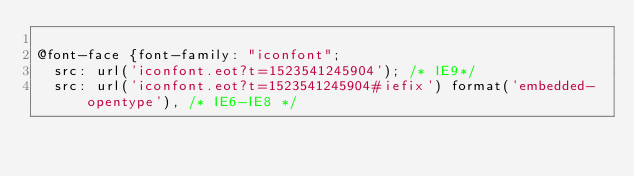Convert code to text. <code><loc_0><loc_0><loc_500><loc_500><_CSS_>
@font-face {font-family: "iconfont";
  src: url('iconfont.eot?t=1523541245904'); /* IE9*/
  src: url('iconfont.eot?t=1523541245904#iefix') format('embedded-opentype'), /* IE6-IE8 */</code> 